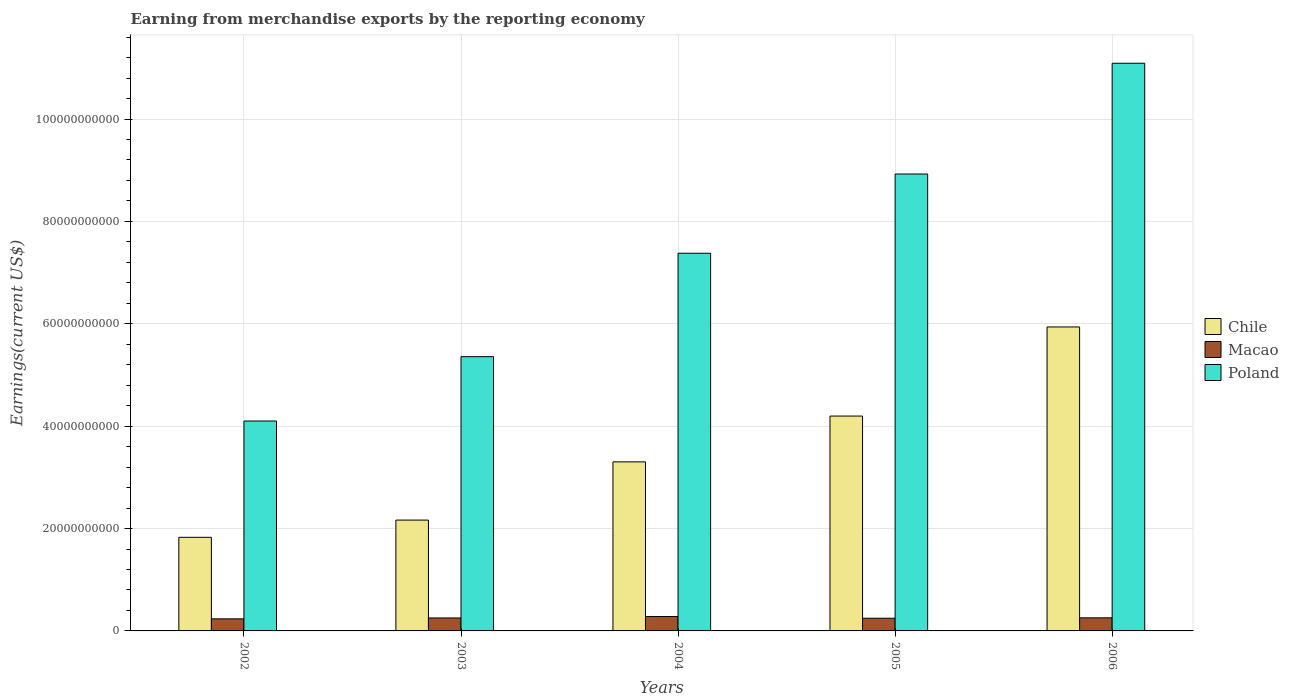How many groups of bars are there?
Offer a terse response. 5. How many bars are there on the 5th tick from the right?
Keep it short and to the point. 3. In how many cases, is the number of bars for a given year not equal to the number of legend labels?
Ensure brevity in your answer.  0. What is the amount earned from merchandise exports in Chile in 2006?
Keep it short and to the point. 5.94e+1. Across all years, what is the maximum amount earned from merchandise exports in Chile?
Your response must be concise. 5.94e+1. Across all years, what is the minimum amount earned from merchandise exports in Macao?
Ensure brevity in your answer.  2.36e+09. In which year was the amount earned from merchandise exports in Poland maximum?
Ensure brevity in your answer.  2006. In which year was the amount earned from merchandise exports in Poland minimum?
Your answer should be very brief. 2002. What is the total amount earned from merchandise exports in Poland in the graph?
Provide a short and direct response. 3.69e+11. What is the difference between the amount earned from merchandise exports in Chile in 2003 and that in 2005?
Ensure brevity in your answer.  -2.03e+1. What is the difference between the amount earned from merchandise exports in Chile in 2006 and the amount earned from merchandise exports in Poland in 2002?
Offer a very short reply. 1.84e+1. What is the average amount earned from merchandise exports in Chile per year?
Your answer should be compact. 3.49e+1. In the year 2005, what is the difference between the amount earned from merchandise exports in Chile and amount earned from merchandise exports in Poland?
Offer a terse response. -4.73e+1. What is the ratio of the amount earned from merchandise exports in Poland in 2003 to that in 2005?
Your response must be concise. 0.6. Is the amount earned from merchandise exports in Macao in 2002 less than that in 2006?
Provide a succinct answer. Yes. Is the difference between the amount earned from merchandise exports in Chile in 2003 and 2006 greater than the difference between the amount earned from merchandise exports in Poland in 2003 and 2006?
Offer a terse response. Yes. What is the difference between the highest and the second highest amount earned from merchandise exports in Macao?
Your response must be concise. 2.54e+08. What is the difference between the highest and the lowest amount earned from merchandise exports in Macao?
Ensure brevity in your answer.  4.53e+08. Is the sum of the amount earned from merchandise exports in Poland in 2003 and 2006 greater than the maximum amount earned from merchandise exports in Chile across all years?
Your response must be concise. Yes. What does the 2nd bar from the right in 2004 represents?
Ensure brevity in your answer.  Macao. How many legend labels are there?
Your answer should be compact. 3. What is the title of the graph?
Offer a terse response. Earning from merchandise exports by the reporting economy. Does "Tunisia" appear as one of the legend labels in the graph?
Provide a succinct answer. No. What is the label or title of the X-axis?
Provide a succinct answer. Years. What is the label or title of the Y-axis?
Keep it short and to the point. Earnings(current US$). What is the Earnings(current US$) in Chile in 2002?
Provide a short and direct response. 1.83e+1. What is the Earnings(current US$) in Macao in 2002?
Your answer should be very brief. 2.36e+09. What is the Earnings(current US$) in Poland in 2002?
Make the answer very short. 4.10e+1. What is the Earnings(current US$) in Chile in 2003?
Ensure brevity in your answer.  2.17e+1. What is the Earnings(current US$) of Macao in 2003?
Give a very brief answer. 2.53e+09. What is the Earnings(current US$) in Poland in 2003?
Ensure brevity in your answer.  5.36e+1. What is the Earnings(current US$) of Chile in 2004?
Give a very brief answer. 3.30e+1. What is the Earnings(current US$) in Macao in 2004?
Provide a succinct answer. 2.81e+09. What is the Earnings(current US$) in Poland in 2004?
Give a very brief answer. 7.38e+1. What is the Earnings(current US$) of Chile in 2005?
Provide a succinct answer. 4.20e+1. What is the Earnings(current US$) in Macao in 2005?
Offer a terse response. 2.48e+09. What is the Earnings(current US$) of Poland in 2005?
Ensure brevity in your answer.  8.93e+1. What is the Earnings(current US$) in Chile in 2006?
Ensure brevity in your answer.  5.94e+1. What is the Earnings(current US$) of Macao in 2006?
Give a very brief answer. 2.56e+09. What is the Earnings(current US$) in Poland in 2006?
Offer a very short reply. 1.11e+11. Across all years, what is the maximum Earnings(current US$) in Chile?
Your response must be concise. 5.94e+1. Across all years, what is the maximum Earnings(current US$) in Macao?
Offer a very short reply. 2.81e+09. Across all years, what is the maximum Earnings(current US$) in Poland?
Your response must be concise. 1.11e+11. Across all years, what is the minimum Earnings(current US$) of Chile?
Your response must be concise. 1.83e+1. Across all years, what is the minimum Earnings(current US$) in Macao?
Offer a very short reply. 2.36e+09. Across all years, what is the minimum Earnings(current US$) of Poland?
Ensure brevity in your answer.  4.10e+1. What is the total Earnings(current US$) of Chile in the graph?
Your answer should be compact. 1.74e+11. What is the total Earnings(current US$) in Macao in the graph?
Give a very brief answer. 1.27e+1. What is the total Earnings(current US$) in Poland in the graph?
Your answer should be compact. 3.69e+11. What is the difference between the Earnings(current US$) of Chile in 2002 and that in 2003?
Give a very brief answer. -3.37e+09. What is the difference between the Earnings(current US$) of Macao in 2002 and that in 2003?
Offer a terse response. -1.74e+08. What is the difference between the Earnings(current US$) of Poland in 2002 and that in 2003?
Your answer should be compact. -1.26e+1. What is the difference between the Earnings(current US$) of Chile in 2002 and that in 2004?
Offer a terse response. -1.47e+1. What is the difference between the Earnings(current US$) in Macao in 2002 and that in 2004?
Your answer should be very brief. -4.53e+08. What is the difference between the Earnings(current US$) of Poland in 2002 and that in 2004?
Offer a very short reply. -3.28e+1. What is the difference between the Earnings(current US$) in Chile in 2002 and that in 2005?
Your answer should be compact. -2.37e+1. What is the difference between the Earnings(current US$) in Macao in 2002 and that in 2005?
Make the answer very short. -1.17e+08. What is the difference between the Earnings(current US$) of Poland in 2002 and that in 2005?
Keep it short and to the point. -4.83e+1. What is the difference between the Earnings(current US$) in Chile in 2002 and that in 2006?
Provide a succinct answer. -4.11e+1. What is the difference between the Earnings(current US$) of Macao in 2002 and that in 2006?
Ensure brevity in your answer.  -1.98e+08. What is the difference between the Earnings(current US$) in Poland in 2002 and that in 2006?
Your response must be concise. -6.99e+1. What is the difference between the Earnings(current US$) in Chile in 2003 and that in 2004?
Offer a terse response. -1.14e+1. What is the difference between the Earnings(current US$) of Macao in 2003 and that in 2004?
Offer a very short reply. -2.79e+08. What is the difference between the Earnings(current US$) of Poland in 2003 and that in 2004?
Ensure brevity in your answer.  -2.02e+1. What is the difference between the Earnings(current US$) in Chile in 2003 and that in 2005?
Your answer should be compact. -2.03e+1. What is the difference between the Earnings(current US$) in Macao in 2003 and that in 2005?
Your answer should be compact. 5.73e+07. What is the difference between the Earnings(current US$) in Poland in 2003 and that in 2005?
Make the answer very short. -3.57e+1. What is the difference between the Earnings(current US$) of Chile in 2003 and that in 2006?
Your answer should be very brief. -3.77e+1. What is the difference between the Earnings(current US$) in Macao in 2003 and that in 2006?
Ensure brevity in your answer.  -2.41e+07. What is the difference between the Earnings(current US$) of Poland in 2003 and that in 2006?
Keep it short and to the point. -5.73e+1. What is the difference between the Earnings(current US$) in Chile in 2004 and that in 2005?
Ensure brevity in your answer.  -8.95e+09. What is the difference between the Earnings(current US$) of Macao in 2004 and that in 2005?
Your answer should be very brief. 3.36e+08. What is the difference between the Earnings(current US$) in Poland in 2004 and that in 2005?
Your answer should be compact. -1.55e+1. What is the difference between the Earnings(current US$) in Chile in 2004 and that in 2006?
Provide a succinct answer. -2.64e+1. What is the difference between the Earnings(current US$) of Macao in 2004 and that in 2006?
Keep it short and to the point. 2.54e+08. What is the difference between the Earnings(current US$) in Poland in 2004 and that in 2006?
Provide a short and direct response. -3.71e+1. What is the difference between the Earnings(current US$) of Chile in 2005 and that in 2006?
Give a very brief answer. -1.74e+1. What is the difference between the Earnings(current US$) of Macao in 2005 and that in 2006?
Offer a very short reply. -8.14e+07. What is the difference between the Earnings(current US$) in Poland in 2005 and that in 2006?
Ensure brevity in your answer.  -2.16e+1. What is the difference between the Earnings(current US$) of Chile in 2002 and the Earnings(current US$) of Macao in 2003?
Keep it short and to the point. 1.58e+1. What is the difference between the Earnings(current US$) in Chile in 2002 and the Earnings(current US$) in Poland in 2003?
Ensure brevity in your answer.  -3.53e+1. What is the difference between the Earnings(current US$) in Macao in 2002 and the Earnings(current US$) in Poland in 2003?
Give a very brief answer. -5.12e+1. What is the difference between the Earnings(current US$) in Chile in 2002 and the Earnings(current US$) in Macao in 2004?
Ensure brevity in your answer.  1.55e+1. What is the difference between the Earnings(current US$) of Chile in 2002 and the Earnings(current US$) of Poland in 2004?
Provide a succinct answer. -5.55e+1. What is the difference between the Earnings(current US$) of Macao in 2002 and the Earnings(current US$) of Poland in 2004?
Give a very brief answer. -7.14e+1. What is the difference between the Earnings(current US$) in Chile in 2002 and the Earnings(current US$) in Macao in 2005?
Ensure brevity in your answer.  1.58e+1. What is the difference between the Earnings(current US$) of Chile in 2002 and the Earnings(current US$) of Poland in 2005?
Your answer should be very brief. -7.10e+1. What is the difference between the Earnings(current US$) in Macao in 2002 and the Earnings(current US$) in Poland in 2005?
Provide a short and direct response. -8.69e+1. What is the difference between the Earnings(current US$) in Chile in 2002 and the Earnings(current US$) in Macao in 2006?
Ensure brevity in your answer.  1.57e+1. What is the difference between the Earnings(current US$) in Chile in 2002 and the Earnings(current US$) in Poland in 2006?
Provide a succinct answer. -9.26e+1. What is the difference between the Earnings(current US$) in Macao in 2002 and the Earnings(current US$) in Poland in 2006?
Provide a short and direct response. -1.09e+11. What is the difference between the Earnings(current US$) of Chile in 2003 and the Earnings(current US$) of Macao in 2004?
Your answer should be very brief. 1.88e+1. What is the difference between the Earnings(current US$) in Chile in 2003 and the Earnings(current US$) in Poland in 2004?
Offer a very short reply. -5.21e+1. What is the difference between the Earnings(current US$) in Macao in 2003 and the Earnings(current US$) in Poland in 2004?
Give a very brief answer. -7.12e+1. What is the difference between the Earnings(current US$) in Chile in 2003 and the Earnings(current US$) in Macao in 2005?
Your response must be concise. 1.92e+1. What is the difference between the Earnings(current US$) in Chile in 2003 and the Earnings(current US$) in Poland in 2005?
Keep it short and to the point. -6.76e+1. What is the difference between the Earnings(current US$) of Macao in 2003 and the Earnings(current US$) of Poland in 2005?
Ensure brevity in your answer.  -8.67e+1. What is the difference between the Earnings(current US$) in Chile in 2003 and the Earnings(current US$) in Macao in 2006?
Give a very brief answer. 1.91e+1. What is the difference between the Earnings(current US$) of Chile in 2003 and the Earnings(current US$) of Poland in 2006?
Ensure brevity in your answer.  -8.92e+1. What is the difference between the Earnings(current US$) in Macao in 2003 and the Earnings(current US$) in Poland in 2006?
Offer a terse response. -1.08e+11. What is the difference between the Earnings(current US$) in Chile in 2004 and the Earnings(current US$) in Macao in 2005?
Keep it short and to the point. 3.05e+1. What is the difference between the Earnings(current US$) of Chile in 2004 and the Earnings(current US$) of Poland in 2005?
Give a very brief answer. -5.62e+1. What is the difference between the Earnings(current US$) in Macao in 2004 and the Earnings(current US$) in Poland in 2005?
Offer a terse response. -8.64e+1. What is the difference between the Earnings(current US$) in Chile in 2004 and the Earnings(current US$) in Macao in 2006?
Your answer should be compact. 3.05e+1. What is the difference between the Earnings(current US$) in Chile in 2004 and the Earnings(current US$) in Poland in 2006?
Provide a short and direct response. -7.79e+1. What is the difference between the Earnings(current US$) in Macao in 2004 and the Earnings(current US$) in Poland in 2006?
Ensure brevity in your answer.  -1.08e+11. What is the difference between the Earnings(current US$) in Chile in 2005 and the Earnings(current US$) in Macao in 2006?
Give a very brief answer. 3.94e+1. What is the difference between the Earnings(current US$) of Chile in 2005 and the Earnings(current US$) of Poland in 2006?
Your answer should be very brief. -6.89e+1. What is the difference between the Earnings(current US$) of Macao in 2005 and the Earnings(current US$) of Poland in 2006?
Make the answer very short. -1.08e+11. What is the average Earnings(current US$) of Chile per year?
Offer a terse response. 3.49e+1. What is the average Earnings(current US$) in Macao per year?
Make the answer very short. 2.55e+09. What is the average Earnings(current US$) of Poland per year?
Make the answer very short. 7.37e+1. In the year 2002, what is the difference between the Earnings(current US$) of Chile and Earnings(current US$) of Macao?
Offer a very short reply. 1.59e+1. In the year 2002, what is the difference between the Earnings(current US$) in Chile and Earnings(current US$) in Poland?
Your response must be concise. -2.27e+1. In the year 2002, what is the difference between the Earnings(current US$) in Macao and Earnings(current US$) in Poland?
Offer a very short reply. -3.87e+1. In the year 2003, what is the difference between the Earnings(current US$) in Chile and Earnings(current US$) in Macao?
Your answer should be compact. 1.91e+1. In the year 2003, what is the difference between the Earnings(current US$) of Chile and Earnings(current US$) of Poland?
Keep it short and to the point. -3.19e+1. In the year 2003, what is the difference between the Earnings(current US$) of Macao and Earnings(current US$) of Poland?
Make the answer very short. -5.10e+1. In the year 2004, what is the difference between the Earnings(current US$) of Chile and Earnings(current US$) of Macao?
Keep it short and to the point. 3.02e+1. In the year 2004, what is the difference between the Earnings(current US$) in Chile and Earnings(current US$) in Poland?
Your answer should be compact. -4.08e+1. In the year 2004, what is the difference between the Earnings(current US$) in Macao and Earnings(current US$) in Poland?
Keep it short and to the point. -7.10e+1. In the year 2005, what is the difference between the Earnings(current US$) of Chile and Earnings(current US$) of Macao?
Your answer should be compact. 3.95e+1. In the year 2005, what is the difference between the Earnings(current US$) in Chile and Earnings(current US$) in Poland?
Give a very brief answer. -4.73e+1. In the year 2005, what is the difference between the Earnings(current US$) in Macao and Earnings(current US$) in Poland?
Provide a short and direct response. -8.68e+1. In the year 2006, what is the difference between the Earnings(current US$) of Chile and Earnings(current US$) of Macao?
Offer a terse response. 5.68e+1. In the year 2006, what is the difference between the Earnings(current US$) of Chile and Earnings(current US$) of Poland?
Offer a very short reply. -5.15e+1. In the year 2006, what is the difference between the Earnings(current US$) in Macao and Earnings(current US$) in Poland?
Ensure brevity in your answer.  -1.08e+11. What is the ratio of the Earnings(current US$) of Chile in 2002 to that in 2003?
Provide a succinct answer. 0.84. What is the ratio of the Earnings(current US$) in Macao in 2002 to that in 2003?
Make the answer very short. 0.93. What is the ratio of the Earnings(current US$) of Poland in 2002 to that in 2003?
Your answer should be very brief. 0.77. What is the ratio of the Earnings(current US$) in Chile in 2002 to that in 2004?
Offer a terse response. 0.55. What is the ratio of the Earnings(current US$) in Macao in 2002 to that in 2004?
Keep it short and to the point. 0.84. What is the ratio of the Earnings(current US$) of Poland in 2002 to that in 2004?
Keep it short and to the point. 0.56. What is the ratio of the Earnings(current US$) in Chile in 2002 to that in 2005?
Your answer should be compact. 0.44. What is the ratio of the Earnings(current US$) in Macao in 2002 to that in 2005?
Make the answer very short. 0.95. What is the ratio of the Earnings(current US$) of Poland in 2002 to that in 2005?
Keep it short and to the point. 0.46. What is the ratio of the Earnings(current US$) in Chile in 2002 to that in 2006?
Give a very brief answer. 0.31. What is the ratio of the Earnings(current US$) in Macao in 2002 to that in 2006?
Your answer should be very brief. 0.92. What is the ratio of the Earnings(current US$) in Poland in 2002 to that in 2006?
Make the answer very short. 0.37. What is the ratio of the Earnings(current US$) in Chile in 2003 to that in 2004?
Offer a terse response. 0.66. What is the ratio of the Earnings(current US$) of Macao in 2003 to that in 2004?
Keep it short and to the point. 0.9. What is the ratio of the Earnings(current US$) of Poland in 2003 to that in 2004?
Give a very brief answer. 0.73. What is the ratio of the Earnings(current US$) of Chile in 2003 to that in 2005?
Your answer should be very brief. 0.52. What is the ratio of the Earnings(current US$) of Macao in 2003 to that in 2005?
Your answer should be very brief. 1.02. What is the ratio of the Earnings(current US$) in Poland in 2003 to that in 2005?
Offer a very short reply. 0.6. What is the ratio of the Earnings(current US$) in Chile in 2003 to that in 2006?
Keep it short and to the point. 0.36. What is the ratio of the Earnings(current US$) of Macao in 2003 to that in 2006?
Offer a very short reply. 0.99. What is the ratio of the Earnings(current US$) of Poland in 2003 to that in 2006?
Ensure brevity in your answer.  0.48. What is the ratio of the Earnings(current US$) of Chile in 2004 to that in 2005?
Offer a terse response. 0.79. What is the ratio of the Earnings(current US$) in Macao in 2004 to that in 2005?
Provide a succinct answer. 1.14. What is the ratio of the Earnings(current US$) of Poland in 2004 to that in 2005?
Offer a very short reply. 0.83. What is the ratio of the Earnings(current US$) in Chile in 2004 to that in 2006?
Make the answer very short. 0.56. What is the ratio of the Earnings(current US$) in Macao in 2004 to that in 2006?
Give a very brief answer. 1.1. What is the ratio of the Earnings(current US$) of Poland in 2004 to that in 2006?
Keep it short and to the point. 0.67. What is the ratio of the Earnings(current US$) of Chile in 2005 to that in 2006?
Give a very brief answer. 0.71. What is the ratio of the Earnings(current US$) of Macao in 2005 to that in 2006?
Ensure brevity in your answer.  0.97. What is the ratio of the Earnings(current US$) of Poland in 2005 to that in 2006?
Offer a terse response. 0.8. What is the difference between the highest and the second highest Earnings(current US$) of Chile?
Offer a terse response. 1.74e+1. What is the difference between the highest and the second highest Earnings(current US$) of Macao?
Provide a short and direct response. 2.54e+08. What is the difference between the highest and the second highest Earnings(current US$) of Poland?
Your answer should be very brief. 2.16e+1. What is the difference between the highest and the lowest Earnings(current US$) in Chile?
Provide a short and direct response. 4.11e+1. What is the difference between the highest and the lowest Earnings(current US$) in Macao?
Your answer should be very brief. 4.53e+08. What is the difference between the highest and the lowest Earnings(current US$) of Poland?
Provide a short and direct response. 6.99e+1. 